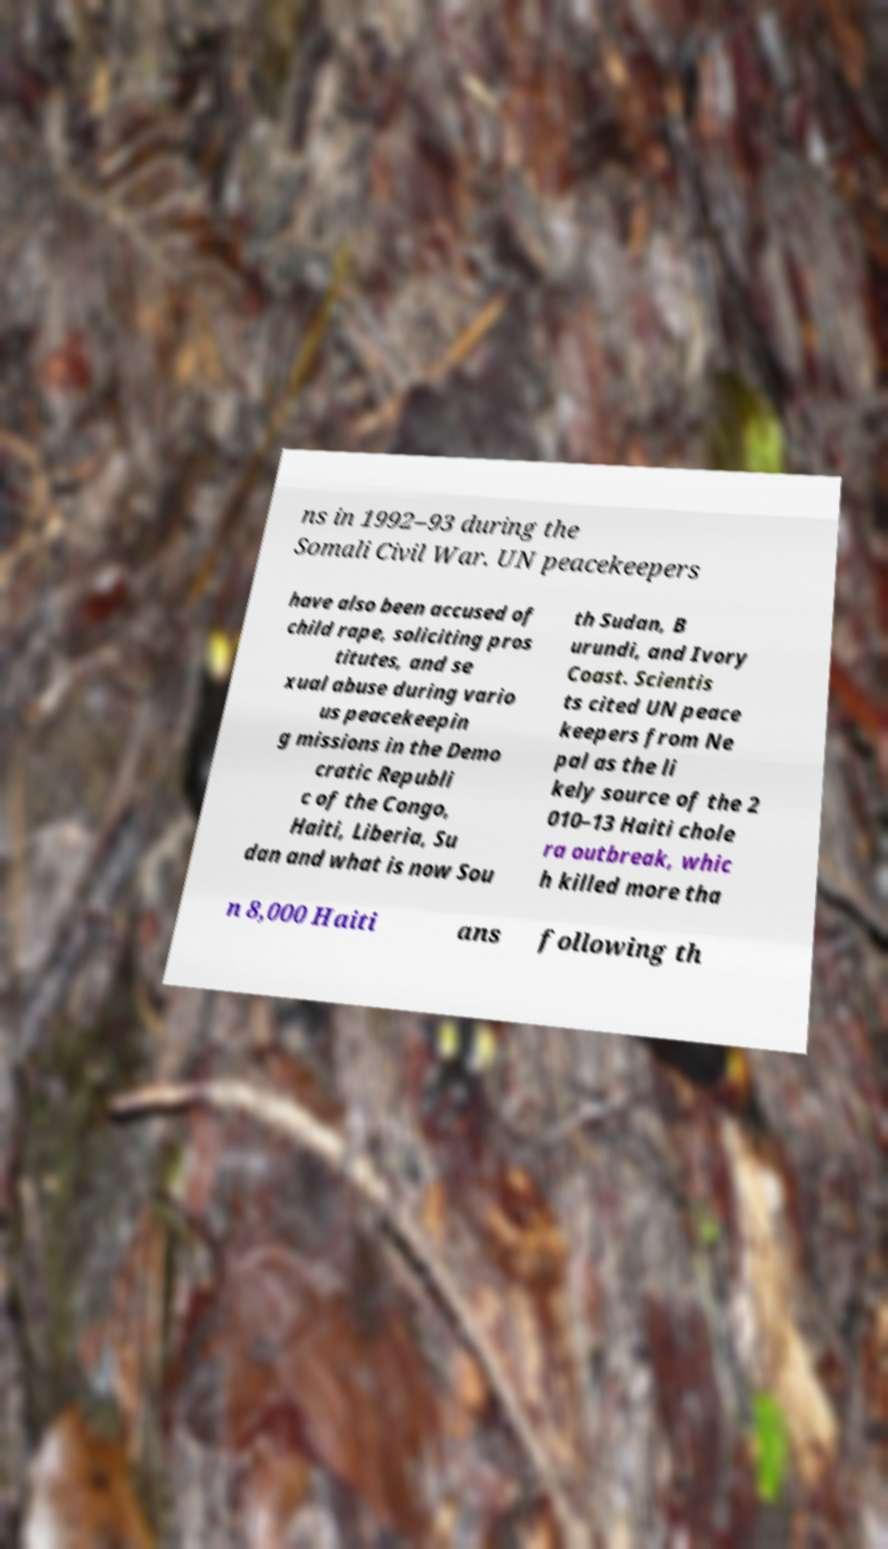Could you assist in decoding the text presented in this image and type it out clearly? ns in 1992–93 during the Somali Civil War. UN peacekeepers have also been accused of child rape, soliciting pros titutes, and se xual abuse during vario us peacekeepin g missions in the Demo cratic Republi c of the Congo, Haiti, Liberia, Su dan and what is now Sou th Sudan, B urundi, and Ivory Coast. Scientis ts cited UN peace keepers from Ne pal as the li kely source of the 2 010–13 Haiti chole ra outbreak, whic h killed more tha n 8,000 Haiti ans following th 